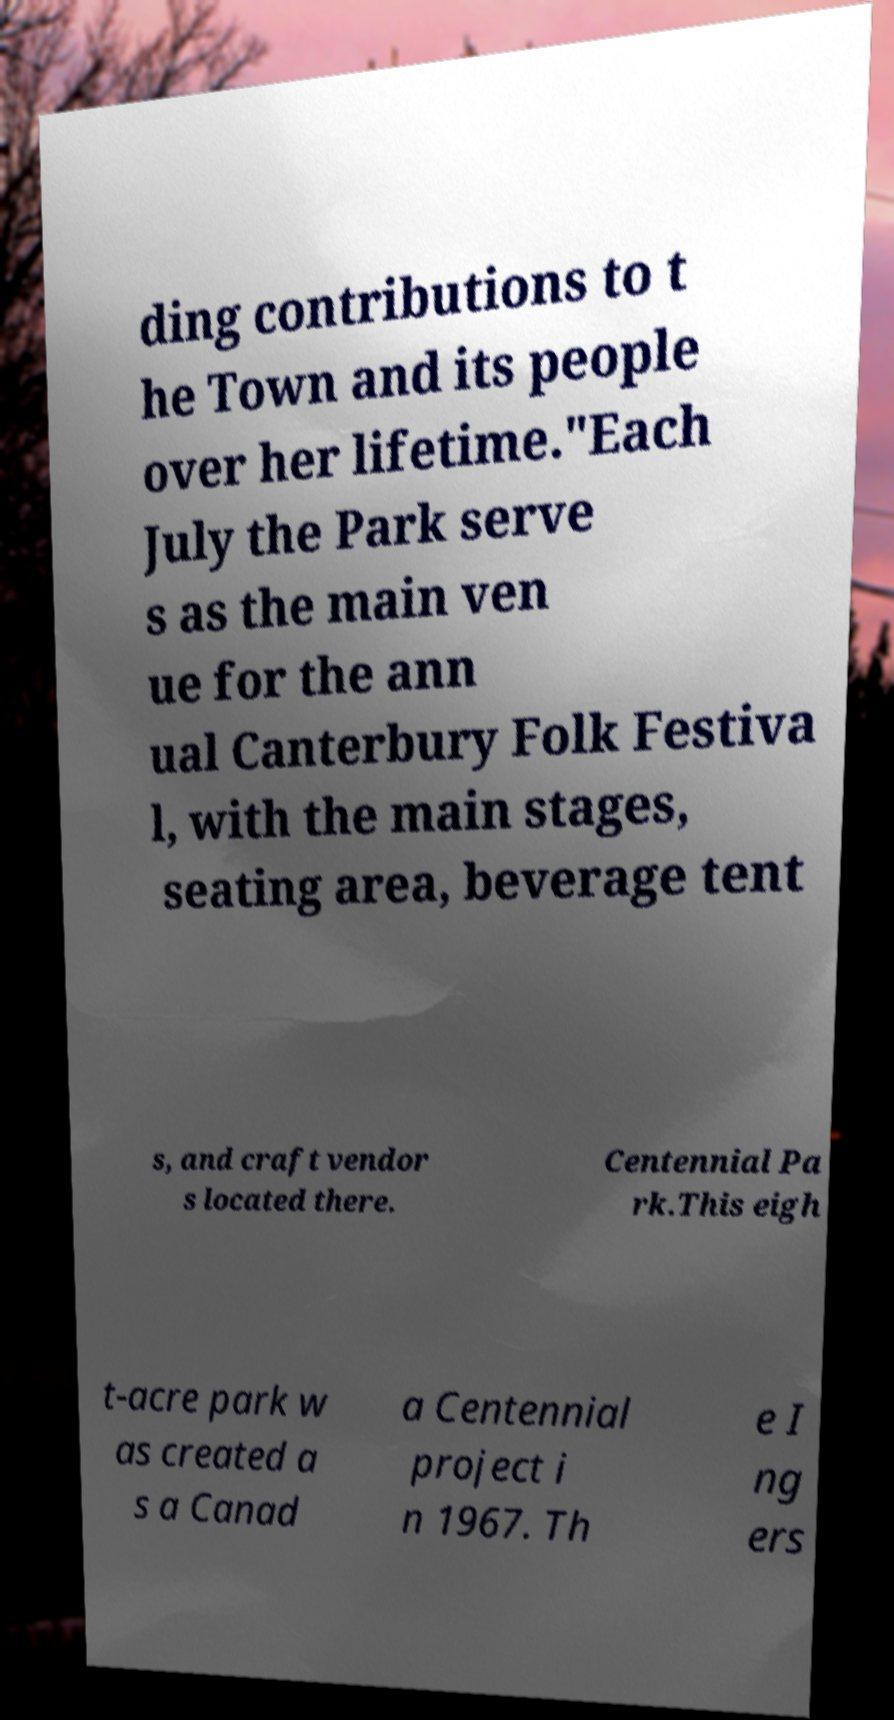Can you read and provide the text displayed in the image?This photo seems to have some interesting text. Can you extract and type it out for me? ding contributions to t he Town and its people over her lifetime."Each July the Park serve s as the main ven ue for the ann ual Canterbury Folk Festiva l, with the main stages, seating area, beverage tent s, and craft vendor s located there. Centennial Pa rk.This eigh t-acre park w as created a s a Canad a Centennial project i n 1967. Th e I ng ers 